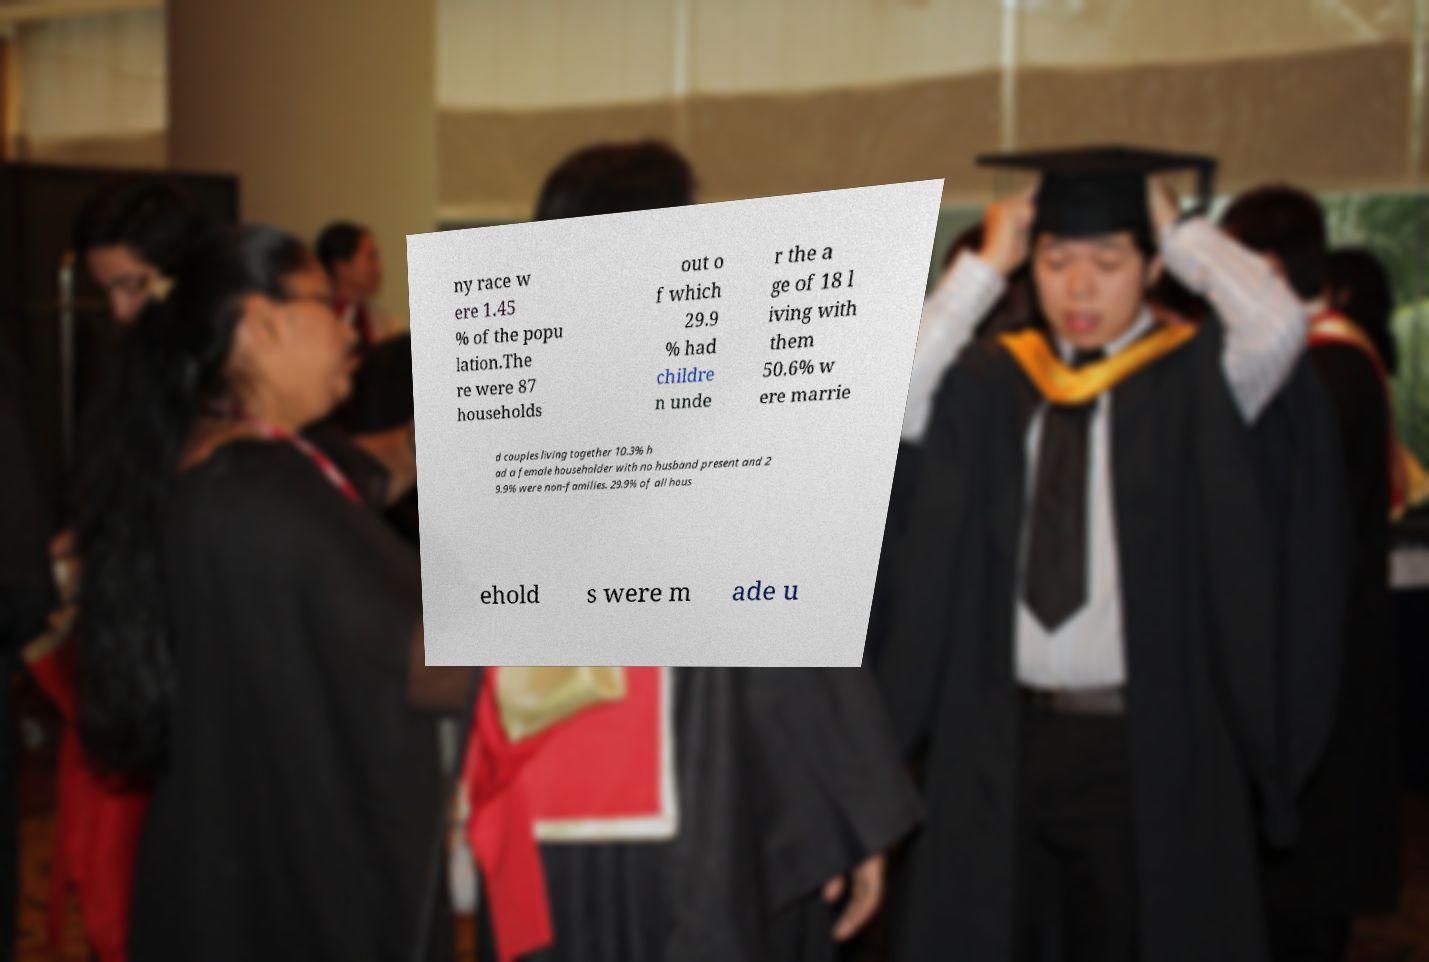Can you read and provide the text displayed in the image?This photo seems to have some interesting text. Can you extract and type it out for me? ny race w ere 1.45 % of the popu lation.The re were 87 households out o f which 29.9 % had childre n unde r the a ge of 18 l iving with them 50.6% w ere marrie d couples living together 10.3% h ad a female householder with no husband present and 2 9.9% were non-families. 29.9% of all hous ehold s were m ade u 